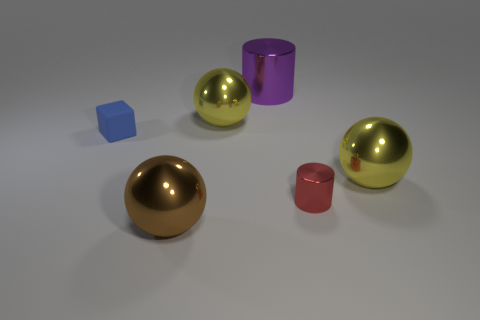How many objects are there in the image, and can you describe their colors? There are five objects in the image. Starting from the left, there is a small blue cube, a large gold sphere, a purple cylinder, a large gold sphere identical to the second object, and finally a small red cylinder. 